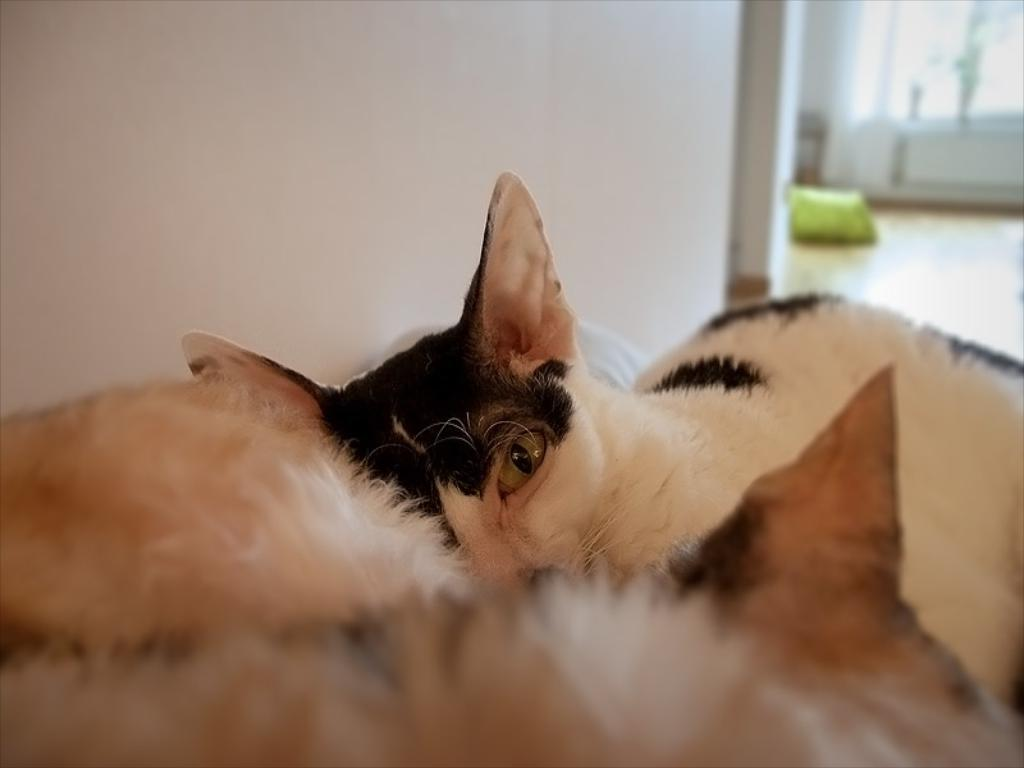What type of animals are in the image? There are cats in the image. Can you describe the color pattern of the cats? The cats are brown and white in color. What is the background of the image? There is a wall in the image. What type of circle can be seen on the linen in the image? There is no circle or linen present in the image; it features cats and a wall. Can you describe the goat in the image? There is no goat present in the image; it features cats and a wall. 